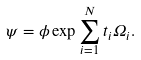Convert formula to latex. <formula><loc_0><loc_0><loc_500><loc_500>\psi = \phi \exp \sum _ { i = 1 } ^ { N } t _ { i } \Omega _ { i } .</formula> 